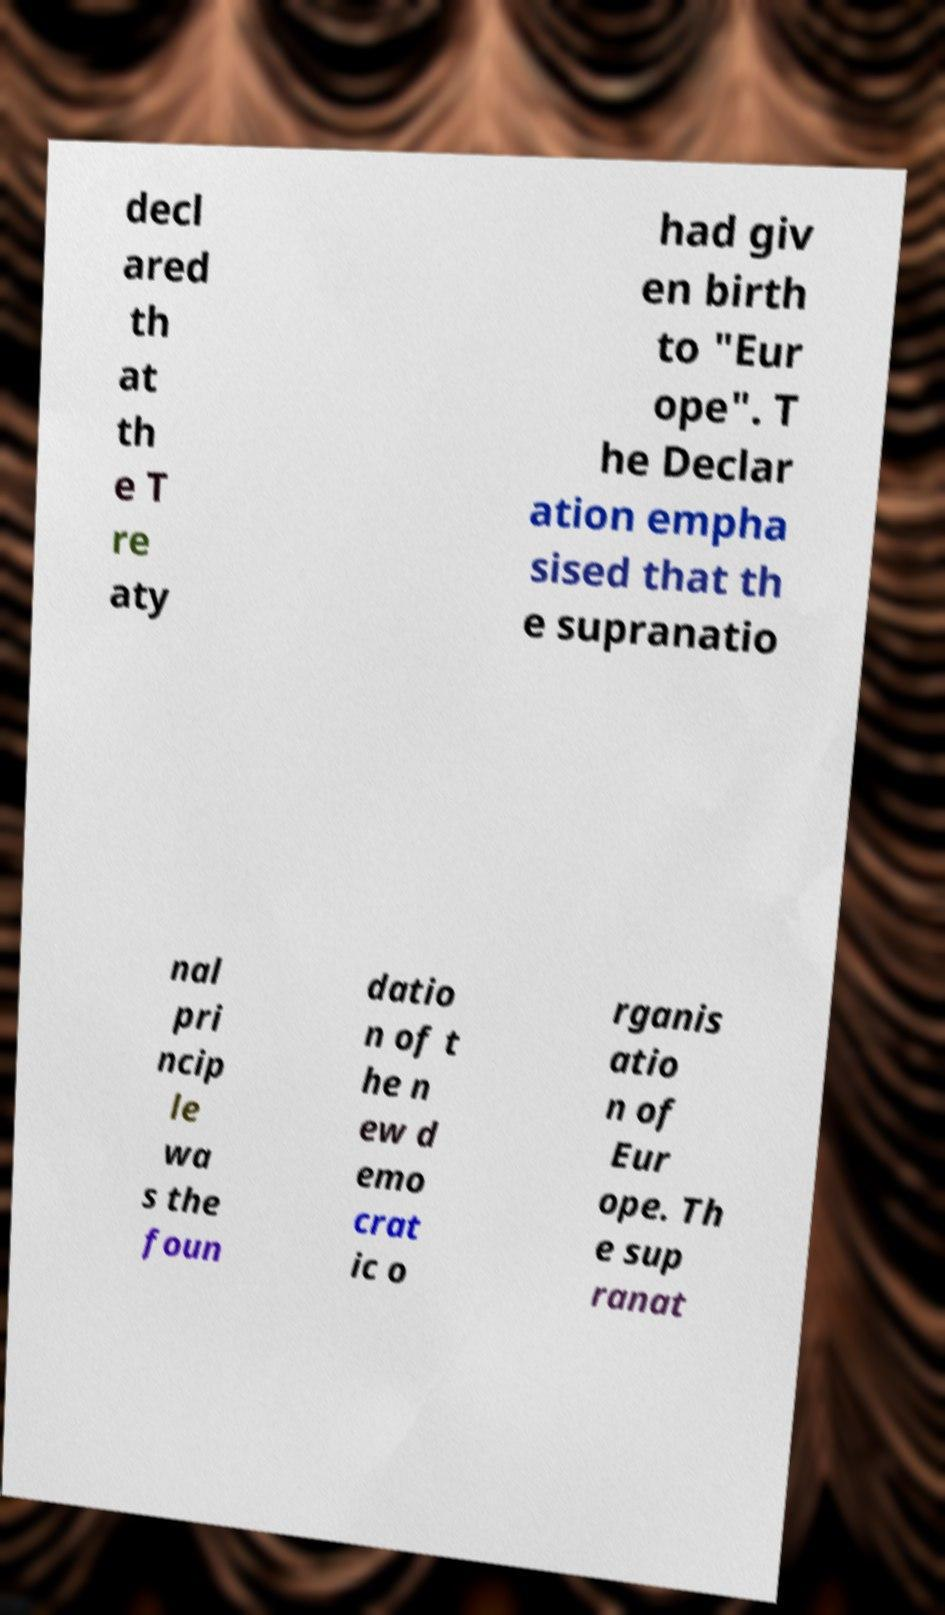What messages or text are displayed in this image? I need them in a readable, typed format. decl ared th at th e T re aty had giv en birth to "Eur ope". T he Declar ation empha sised that th e supranatio nal pri ncip le wa s the foun datio n of t he n ew d emo crat ic o rganis atio n of Eur ope. Th e sup ranat 